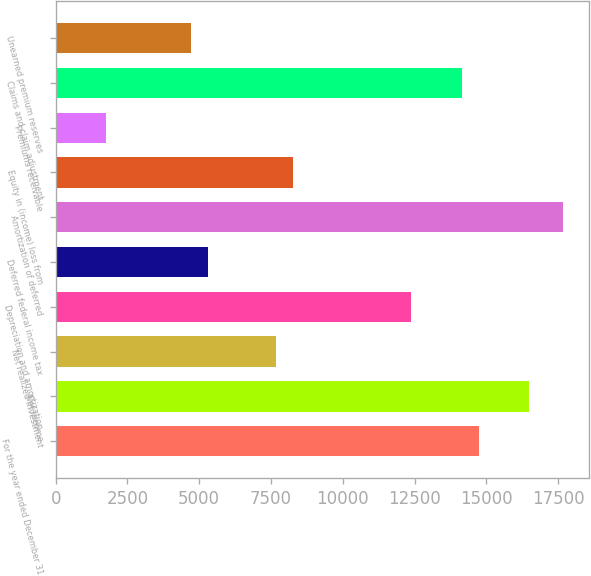Convert chart. <chart><loc_0><loc_0><loc_500><loc_500><bar_chart><fcel>For the year ended December 31<fcel>Net income<fcel>Net realized investment<fcel>Depreciation and amortization<fcel>Deferred federal income tax<fcel>Amortization of deferred<fcel>Equity in (income) loss from<fcel>Premiums receivable<fcel>Claims and claim adjustment<fcel>Unearned premium reserves<nl><fcel>14735.5<fcel>16503.4<fcel>7663.9<fcel>12378.3<fcel>5306.7<fcel>17682<fcel>8253.2<fcel>1770.9<fcel>14146.2<fcel>4717.4<nl></chart> 